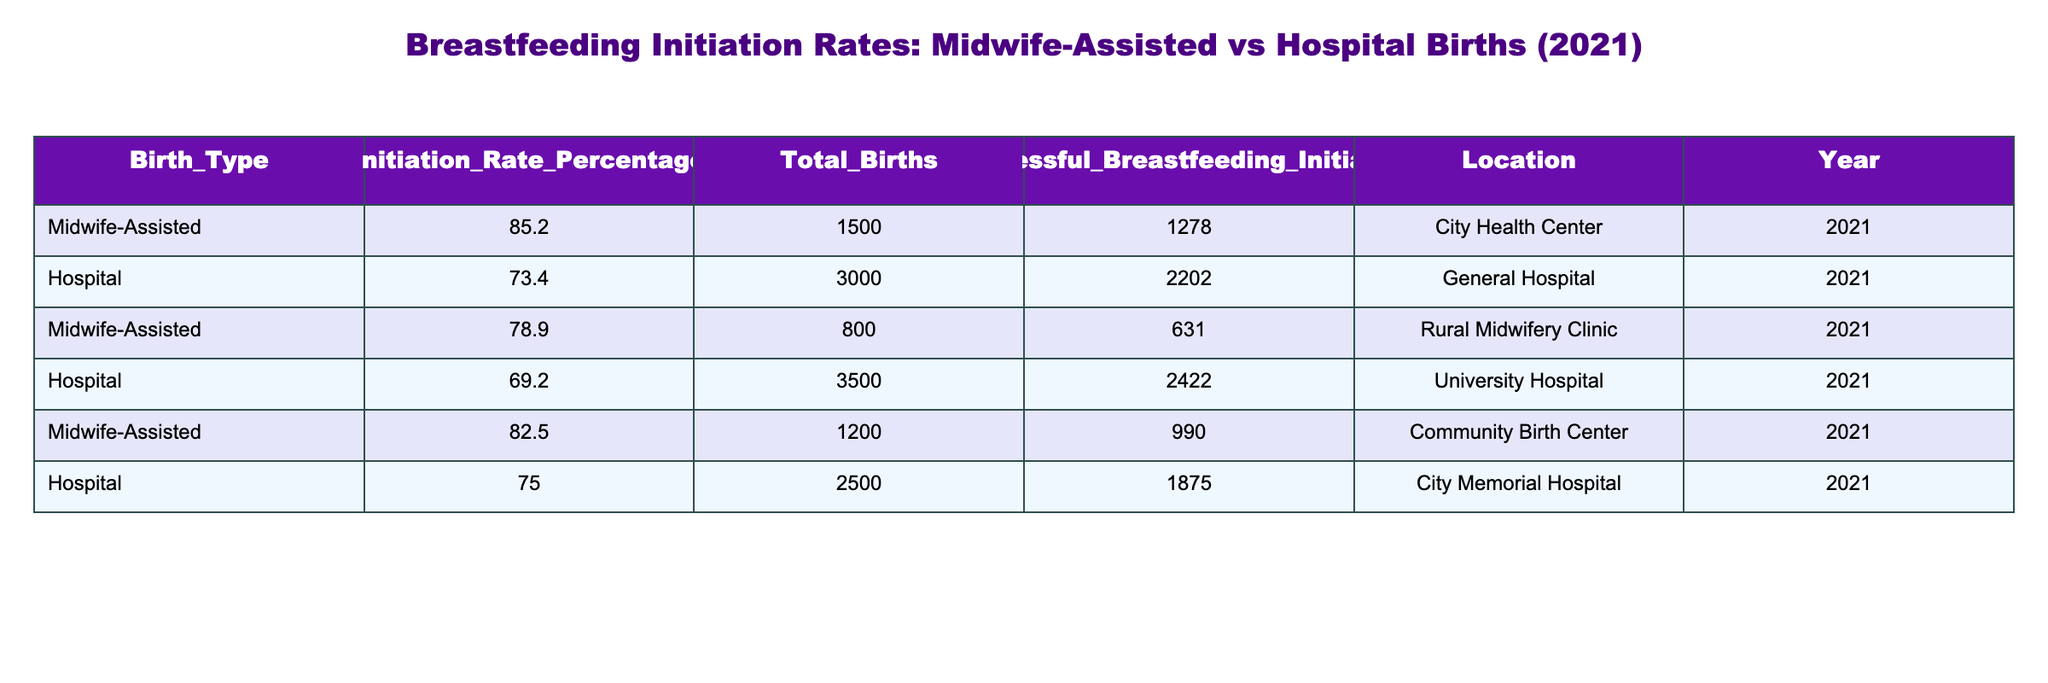What is the initiation rate percentage for midwife-assisted births? The initiation rate percentage for midwife-assisted births can be found in the table under the "Initiation_Rate_Percentage" column for the row where "Birth_Type" is "Midwife-Assisted". The value is 85.2%.
Answer: 85.2% Which hospital had the highest breastfeeding initiation rate? To find which hospital had the highest breastfeeding initiation rate, we look at the "Initiation_Rate_Percentage" for the rows under "Hospital". The rates are 73.4%, 69.2%, and 75.0%. The highest among these is 75.0% from the City Memorial Hospital.
Answer: City Memorial Hospital What is the average breastfeeding initiation rate for both midwife-assisted and hospital births combined? First, we gather all the initiation rates: 85.2, 73.4, 78.9, 69.2, 82.5, and 75.0. Adding these gives 464.2. There are a total of 6 data points; thus, the average is calculated as 464.2 / 6 = 77.3667, which rounds to 77.37.
Answer: 77.37 Is the breastfeeding initiation rate higher for midwife-assisted births compared to hospital births? We will compare the highest initiation rates of both types of births. The highest rate for midwife-assisted births is 85.2%, while the highest for hospital births is 75.0%. Since 85.2% is greater than 75.0%, the statement is true.
Answer: Yes How many total births were recorded for midwife-assisted and hospital births combined? We add the "Total_Births" for midwife-assisted (1500 + 800 + 1200) which equals 2500 and for hospital births (3000 + 3500 + 2500) which equals 9000. Combining both totals gives us 2500 + 9000 = 11500.
Answer: 11500 What percentage of successful breastfeeding initiations was observed in the Rural Midwifery Clinic? The percentage of successful breastfeeding initiations is given in the "Initiation_Rate_Percentage" column for the "Rural Midwifery Clinic". The value is 78.9%.
Answer: 78.9% Which type of birth had a total of 3000 births in the table? Looking at the "Total_Births" column for each birth type, we find that "Hospital" has a total of 3000 births listed in the "General Hospital" row.
Answer: Hospital What is the difference in successful breastfeeding initiations between the University Hospital and the Community Birth Center? We will subtract the successful breastfeeding initiations for the University Hospital (2422) from that of the Community Birth Center (990). So, 2422 - 990 = 1432.
Answer: 1432 